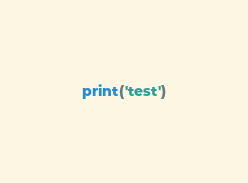<code> <loc_0><loc_0><loc_500><loc_500><_Python_>print('test')</code> 